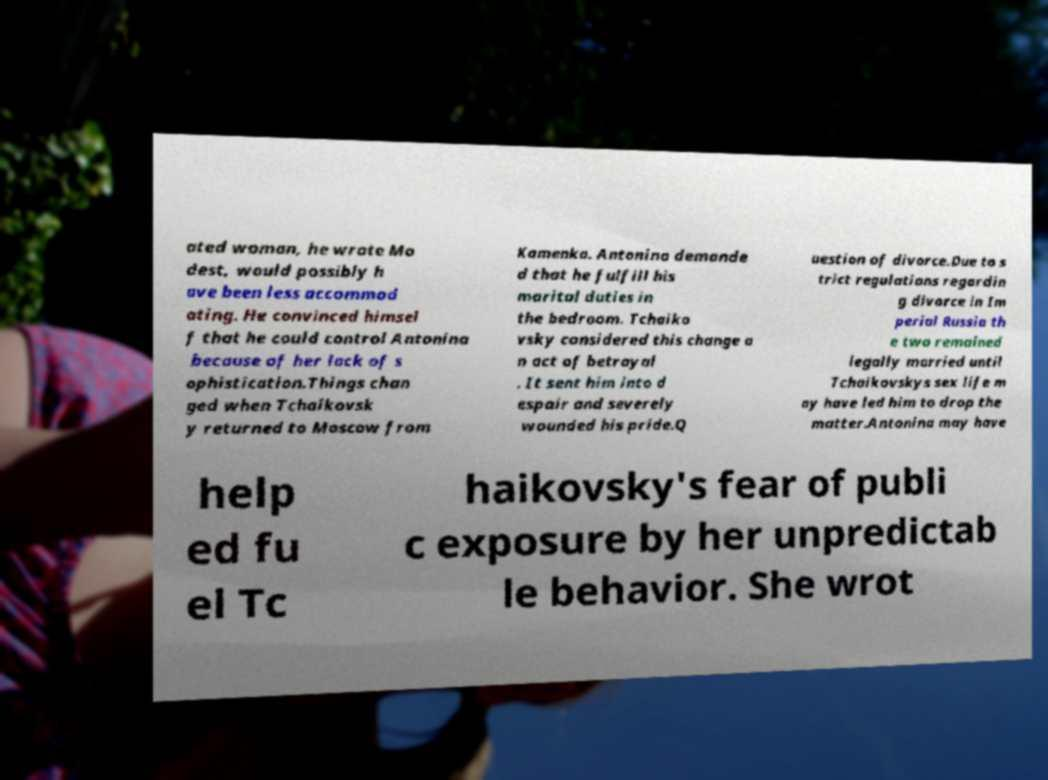Could you extract and type out the text from this image? ated woman, he wrote Mo dest, would possibly h ave been less accommod ating. He convinced himsel f that he could control Antonina because of her lack of s ophistication.Things chan ged when Tchaikovsk y returned to Moscow from Kamenka. Antonina demande d that he fulfill his marital duties in the bedroom. Tchaiko vsky considered this change a n act of betrayal . It sent him into d espair and severely wounded his pride.Q uestion of divorce.Due to s trict regulations regardin g divorce in Im perial Russia th e two remained legally married until Tchaikovskys sex life m ay have led him to drop the matter.Antonina may have help ed fu el Tc haikovsky's fear of publi c exposure by her unpredictab le behavior. She wrot 